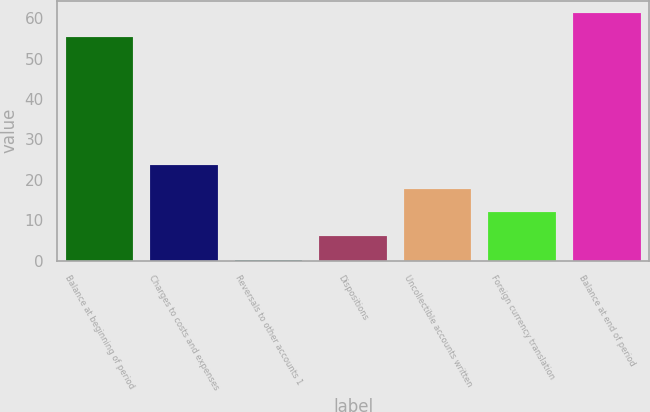Convert chart to OTSL. <chart><loc_0><loc_0><loc_500><loc_500><bar_chart><fcel>Balance at beginning of period<fcel>Charges to costs and expenses<fcel>Reversals to other accounts 1<fcel>Dispositions<fcel>Uncollectible accounts written<fcel>Foreign currency translation<fcel>Balance at end of period<nl><fcel>55.4<fcel>23.72<fcel>0.2<fcel>6.08<fcel>17.84<fcel>11.96<fcel>61.28<nl></chart> 